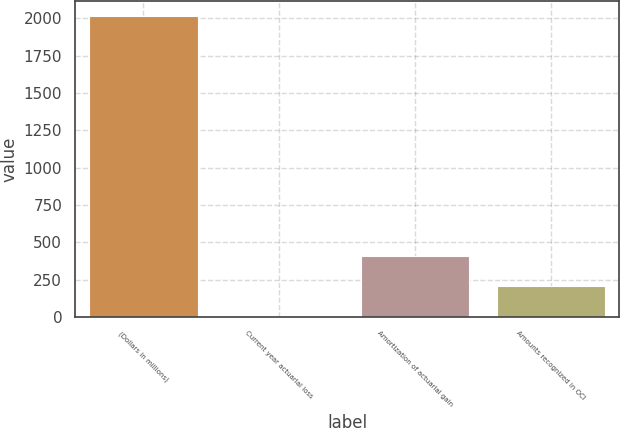Convert chart to OTSL. <chart><loc_0><loc_0><loc_500><loc_500><bar_chart><fcel>(Dollars in millions)<fcel>Current year actuarial loss<fcel>Amortization of actuarial gain<fcel>Amounts recognized in OCI<nl><fcel>2017<fcel>7<fcel>409<fcel>208<nl></chart> 